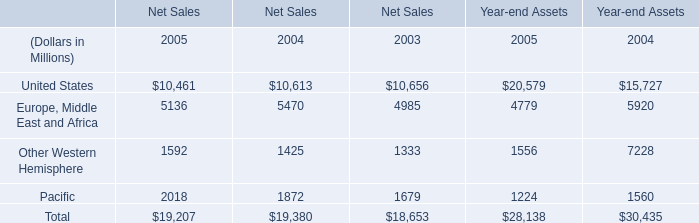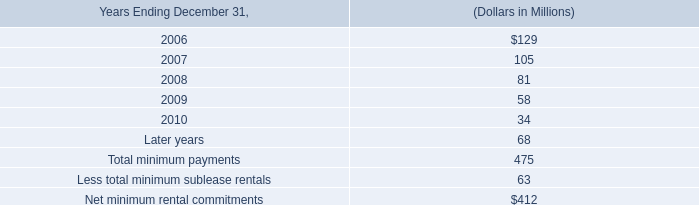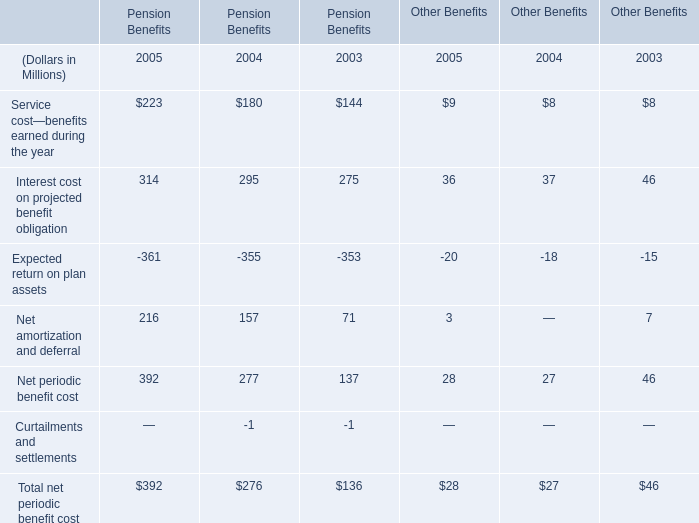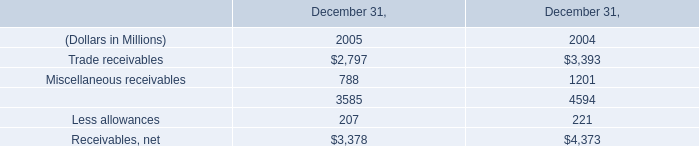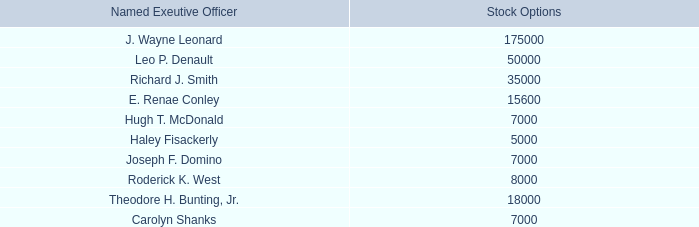What will United States in Net Sales be like in 2006 if it continues to grow at the same rate as it did in 2005? (in millions) 
Computations: ((1 + ((10461 - 10613) / 10613)) * 10461)
Answer: 10311.17695. 